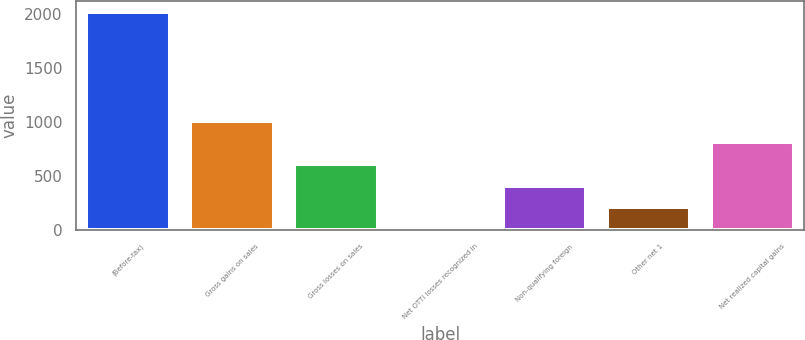<chart> <loc_0><loc_0><loc_500><loc_500><bar_chart><fcel>(Before-tax)<fcel>Gross gains on sales<fcel>Gross losses on sales<fcel>Net OTTI losses recognized in<fcel>Non-qualifying foreign<fcel>Other net 1<fcel>Net realized capital gains<nl><fcel>2017<fcel>1012.5<fcel>610.7<fcel>8<fcel>409.8<fcel>208.9<fcel>811.6<nl></chart> 